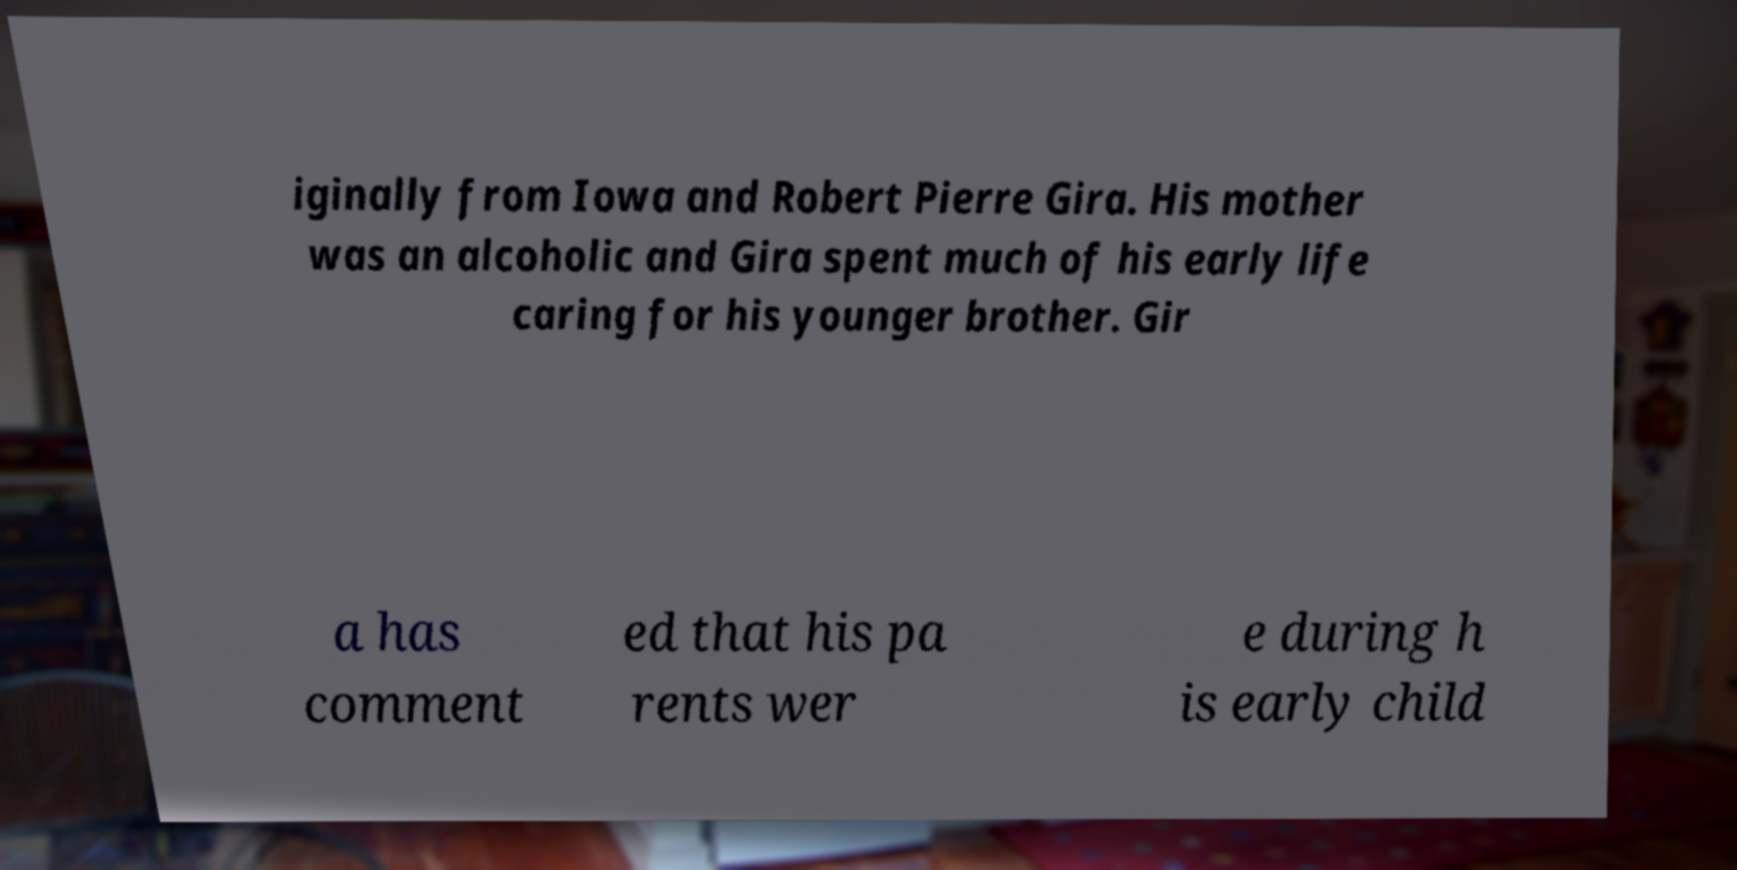Can you accurately transcribe the text from the provided image for me? iginally from Iowa and Robert Pierre Gira. His mother was an alcoholic and Gira spent much of his early life caring for his younger brother. Gir a has comment ed that his pa rents wer e during h is early child 